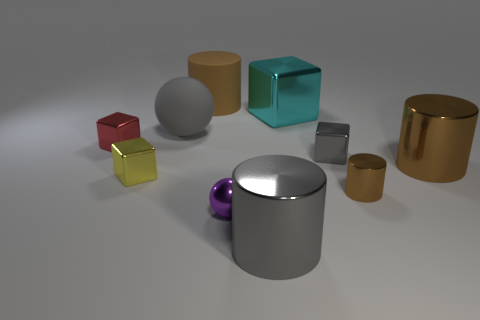There is a rubber cylinder; does it have the same color as the metal cylinder that is behind the small shiny cylinder?
Make the answer very short. Yes. Does the gray thing left of the brown matte cylinder have the same shape as the purple metal object?
Your answer should be compact. Yes. What number of things are behind the tiny red shiny object and to the right of the tiny purple metallic thing?
Your answer should be compact. 1. The large metal thing behind the large brown object to the right of the brown thing behind the large cyan cube is what color?
Provide a short and direct response. Cyan. There is a tiny block that is on the right side of the gray shiny cylinder; how many brown cylinders are on the left side of it?
Ensure brevity in your answer.  1. What number of other things are there of the same shape as the small brown metal thing?
Offer a terse response. 3. What number of things are big cyan metallic blocks or large objects right of the shiny ball?
Provide a succinct answer. 3. Is the number of small balls that are behind the gray matte ball greater than the number of large brown shiny cylinders that are left of the tiny gray block?
Ensure brevity in your answer.  No. The brown thing in front of the yellow metal thing in front of the small block that is to the right of the purple object is what shape?
Offer a terse response. Cylinder. There is a big matte thing behind the sphere behind the tiny cylinder; what is its shape?
Your answer should be compact. Cylinder. 